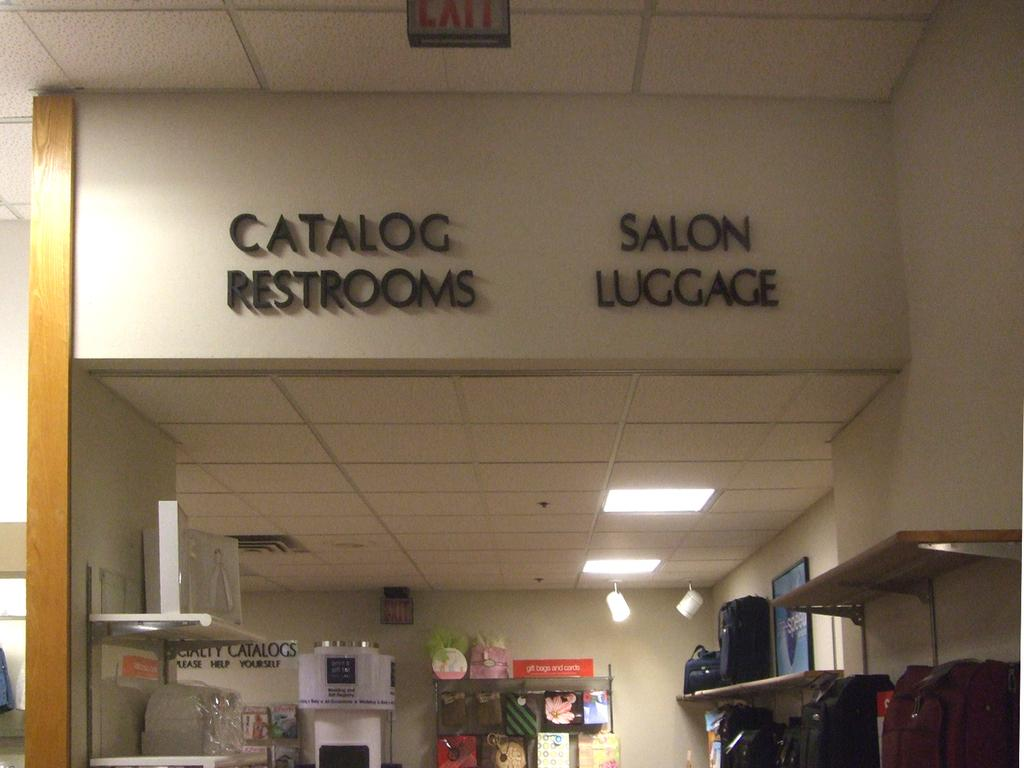<image>
Summarize the visual content of the image. Catalog restrooms and salon luggage inside a building 